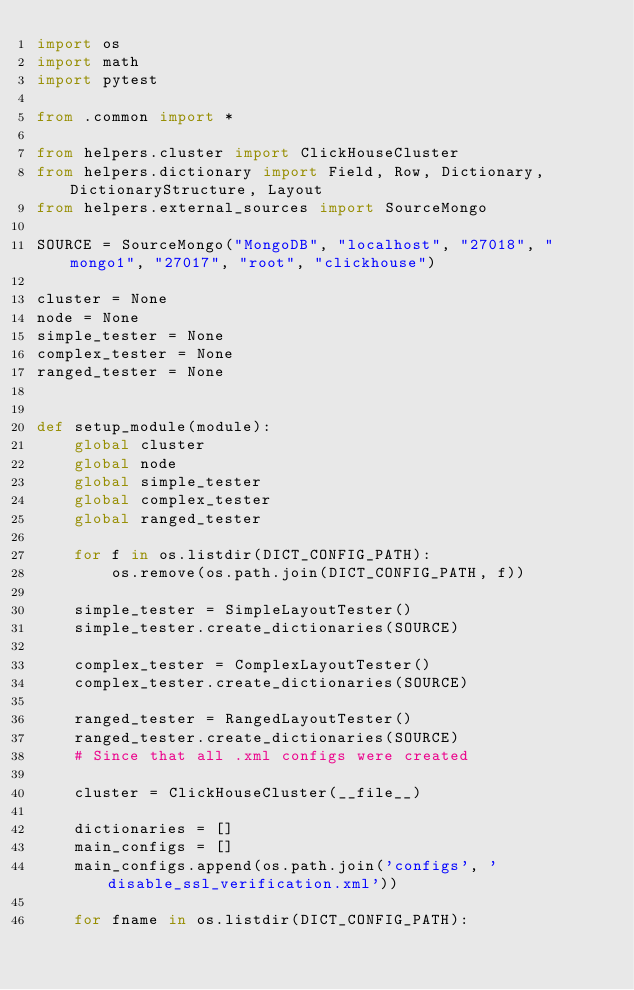<code> <loc_0><loc_0><loc_500><loc_500><_Python_>import os 
import math
import pytest

from .common import *

from helpers.cluster import ClickHouseCluster
from helpers.dictionary import Field, Row, Dictionary, DictionaryStructure, Layout
from helpers.external_sources import SourceMongo

SOURCE = SourceMongo("MongoDB", "localhost", "27018", "mongo1", "27017", "root", "clickhouse")

cluster = None
node = None
simple_tester = None
complex_tester = None
ranged_tester = None


def setup_module(module):
    global cluster
    global node
    global simple_tester
    global complex_tester
    global ranged_tester

    for f in os.listdir(DICT_CONFIG_PATH):
        os.remove(os.path.join(DICT_CONFIG_PATH, f))

    simple_tester = SimpleLayoutTester()
    simple_tester.create_dictionaries(SOURCE)

    complex_tester = ComplexLayoutTester()
    complex_tester.create_dictionaries(SOURCE)

    ranged_tester = RangedLayoutTester()
    ranged_tester.create_dictionaries(SOURCE)
    # Since that all .xml configs were created

    cluster = ClickHouseCluster(__file__)

    dictionaries = []
    main_configs = []
    main_configs.append(os.path.join('configs', 'disable_ssl_verification.xml'))
    
    for fname in os.listdir(DICT_CONFIG_PATH):</code> 